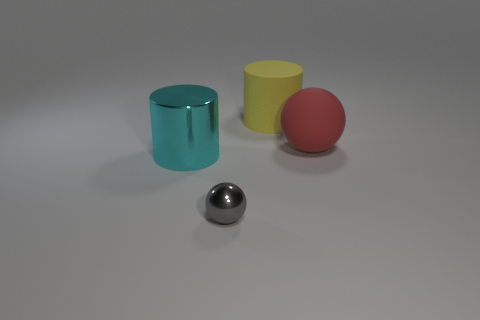There is a rubber ball; does it have the same color as the metal object that is on the left side of the small gray metallic ball?
Provide a succinct answer. No. What is the size of the thing that is in front of the yellow matte object and behind the large cyan metal thing?
Keep it short and to the point. Large. How many other things are there of the same color as the small metal ball?
Ensure brevity in your answer.  0. What size is the cylinder behind the sphere that is behind the cylinder left of the yellow rubber cylinder?
Make the answer very short. Large. There is a large yellow matte cylinder; are there any matte balls to the left of it?
Offer a very short reply. No. There is a cyan cylinder; does it have the same size as the object behind the red thing?
Your response must be concise. Yes. How many other objects are the same material as the red object?
Your answer should be very brief. 1. What shape is the large thing that is both left of the large matte sphere and right of the large cyan shiny thing?
Offer a very short reply. Cylinder. There is a ball on the left side of the large red object; is it the same size as the red thing that is behind the big cyan metallic cylinder?
Make the answer very short. No. There is a tiny thing that is the same material as the large cyan cylinder; what shape is it?
Ensure brevity in your answer.  Sphere. 